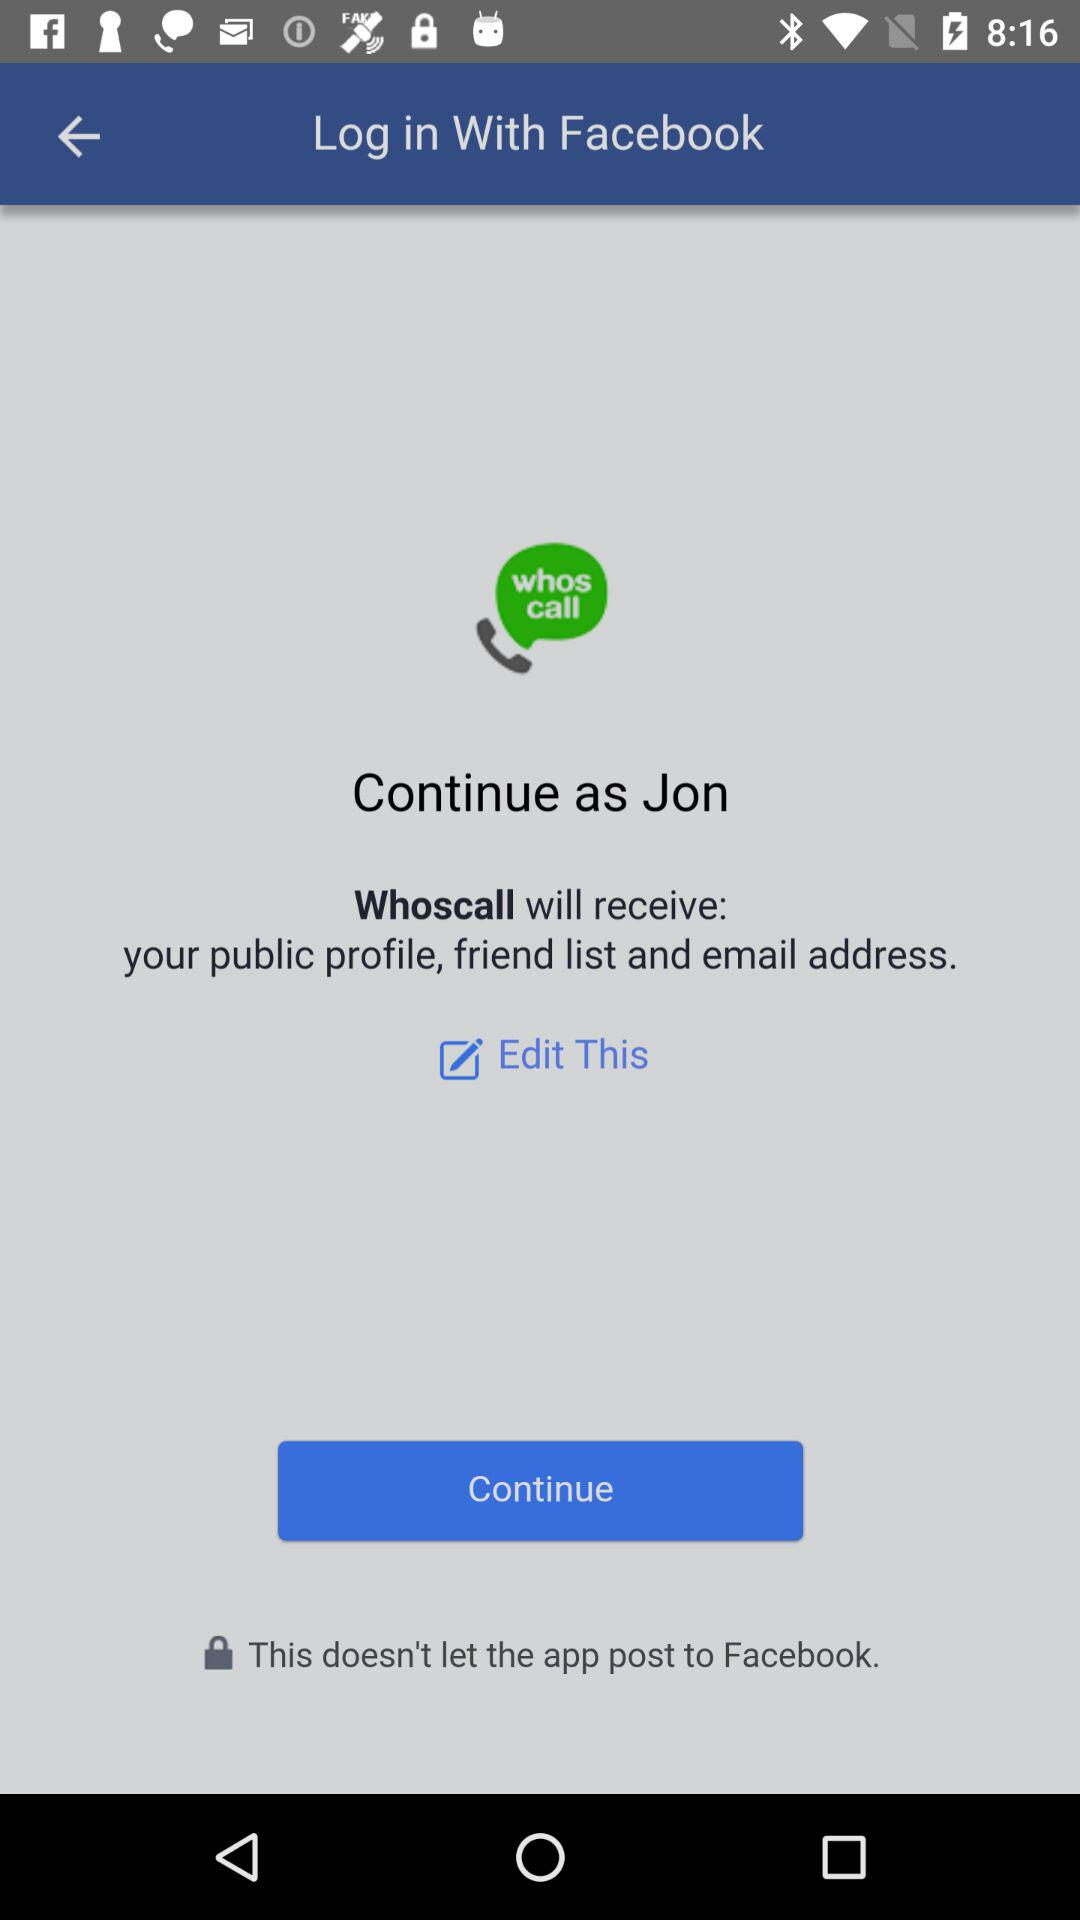What application will receive my public profile, email address and friend list? The application "Whoscall" will receive your public profile, email address and friend list. 